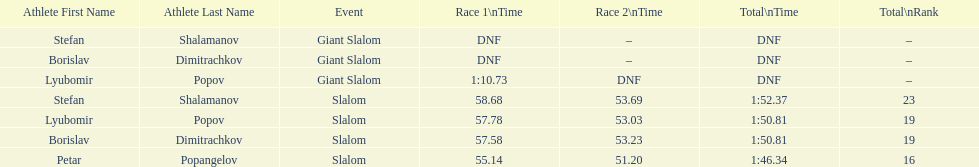Could you parse the entire table? {'header': ['Athlete First Name', 'Athlete Last Name', 'Event', 'Race 1\\nTime', 'Race 2\\nTime', 'Total\\nTime', 'Total\\nRank'], 'rows': [['Stefan', 'Shalamanov', 'Giant Slalom', 'DNF', '–', 'DNF', '–'], ['Borislav', 'Dimitrachkov', 'Giant Slalom', 'DNF', '–', 'DNF', '–'], ['Lyubomir', 'Popov', 'Giant Slalom', '1:10.73', 'DNF', 'DNF', '–'], ['Stefan', 'Shalamanov', 'Slalom', '58.68', '53.69', '1:52.37', '23'], ['Lyubomir', 'Popov', 'Slalom', '57.78', '53.03', '1:50.81', '19'], ['Borislav', 'Dimitrachkov', 'Slalom', '57.58', '53.23', '1:50.81', '19'], ['Petar', 'Popangelov', 'Slalom', '55.14', '51.20', '1:46.34', '16']]} How many athletes are there total? 4. 